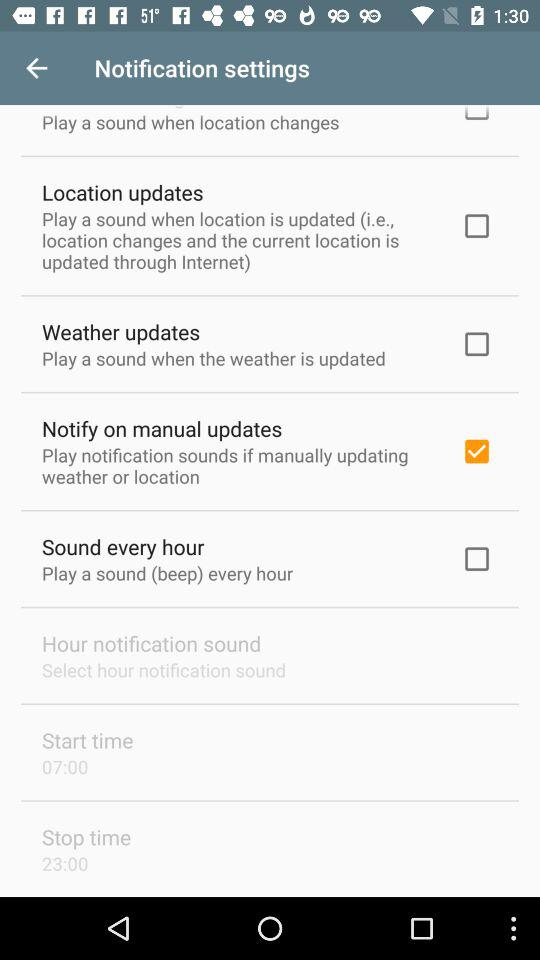What is the status of "Weather updates"? The status is "off". 